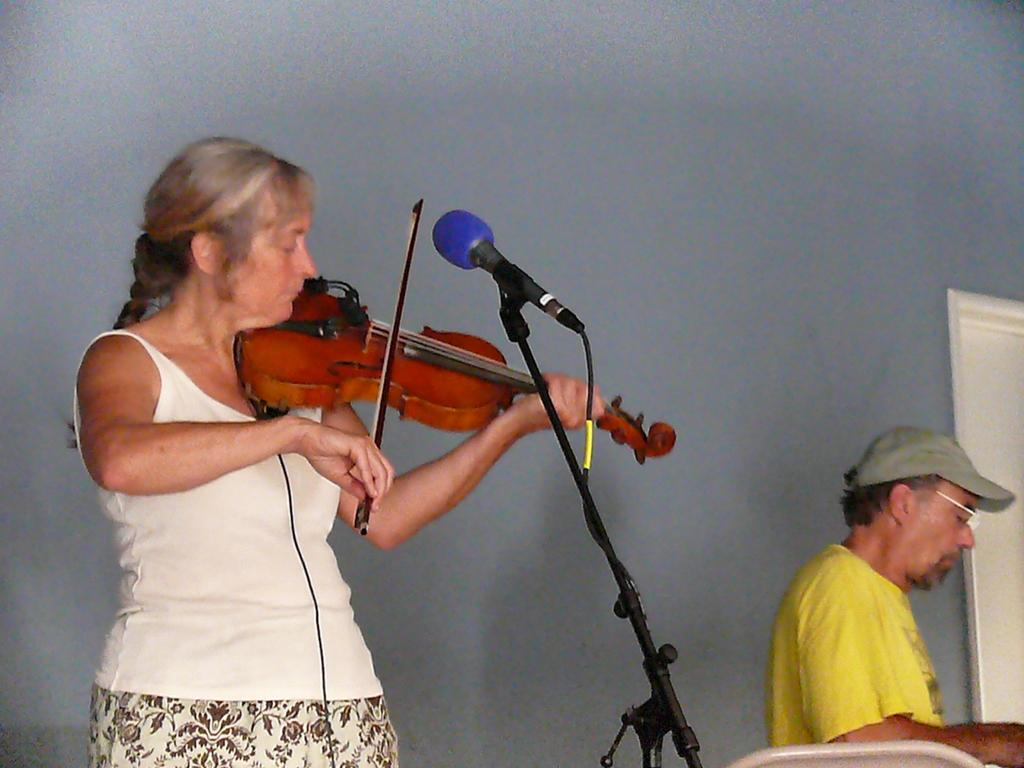What is the lady in the image doing? The lady in the image is playing the violin. What object is in front of the lady? There is a speaker in front of the lady. Can you describe the man in the image? There is a man on the right bottom of the image. What type of brass horn can be seen in the image? There is no brass horn present in the image. 